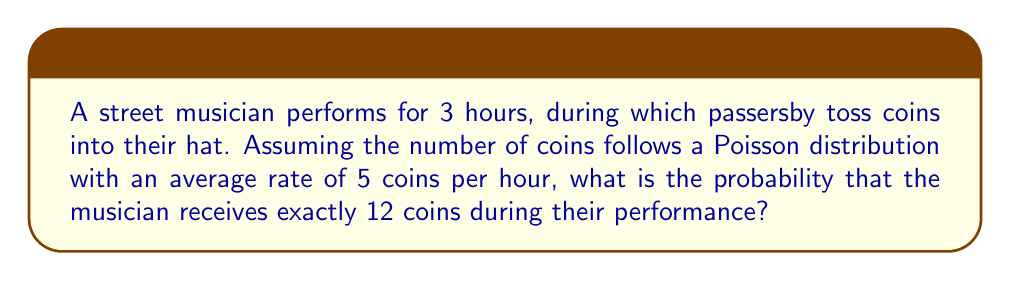Help me with this question. Let's approach this step-by-step:

1) The Poisson distribution is given by the formula:

   $$P(X = k) = \frac{e^{-\lambda} \lambda^k}{k!}$$

   where $\lambda$ is the average rate of events and $k$ is the number of events.

2) In this case:
   - $\lambda = 5$ coins/hour * 3 hours = 15 coins (for the entire performance)
   - $k = 12$ coins

3) Plugging these values into the formula:

   $$P(X = 12) = \frac{e^{-15} 15^{12}}{12!}$$

4) Let's calculate this step-by-step:
   
   a) $e^{-15} \approx 3.059 \times 10^{-7}$
   
   b) $15^{12} = 129,746,337,890,625$
   
   c) $12! = 479,001,600$

5) Now, let's put it all together:

   $$P(X = 12) = \frac{3.059 \times 10^{-7} \times 129,746,337,890,625}{479,001,600}$$

6) Simplifying:

   $$P(X = 12) \approx 0.0826$$

Therefore, the probability of receiving exactly 12 coins during the 3-hour performance is approximately 0.0826 or 8.26%.
Answer: $0.0826$ or $8.26\%$ 